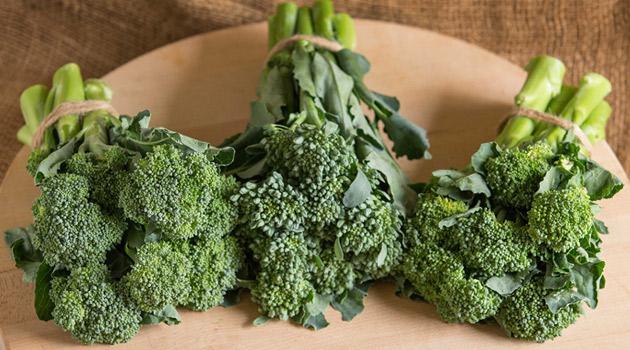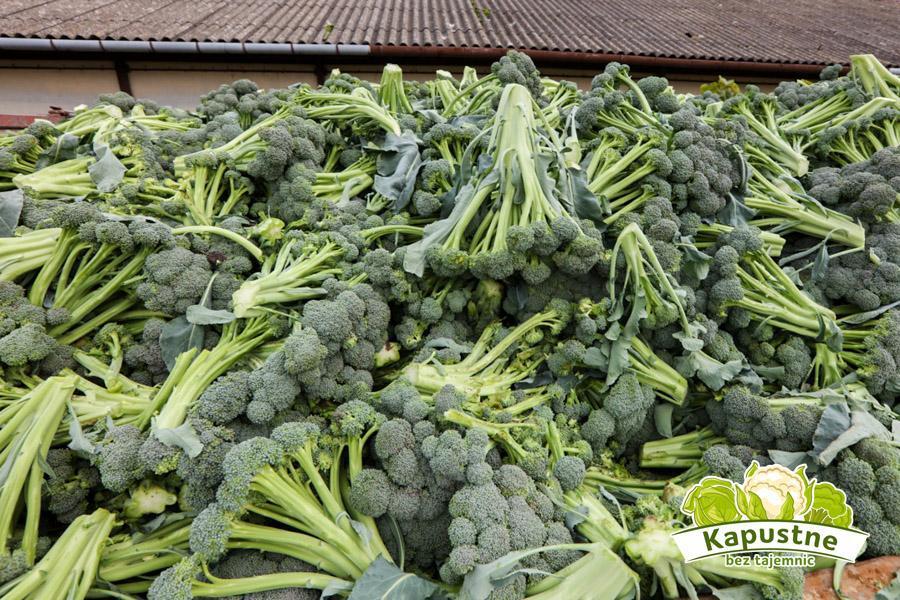The first image is the image on the left, the second image is the image on the right. Evaluate the accuracy of this statement regarding the images: "In the image to the left, you're able to see some of the broad leaves of the broccoli plant.". Is it true? Answer yes or no. Yes. 